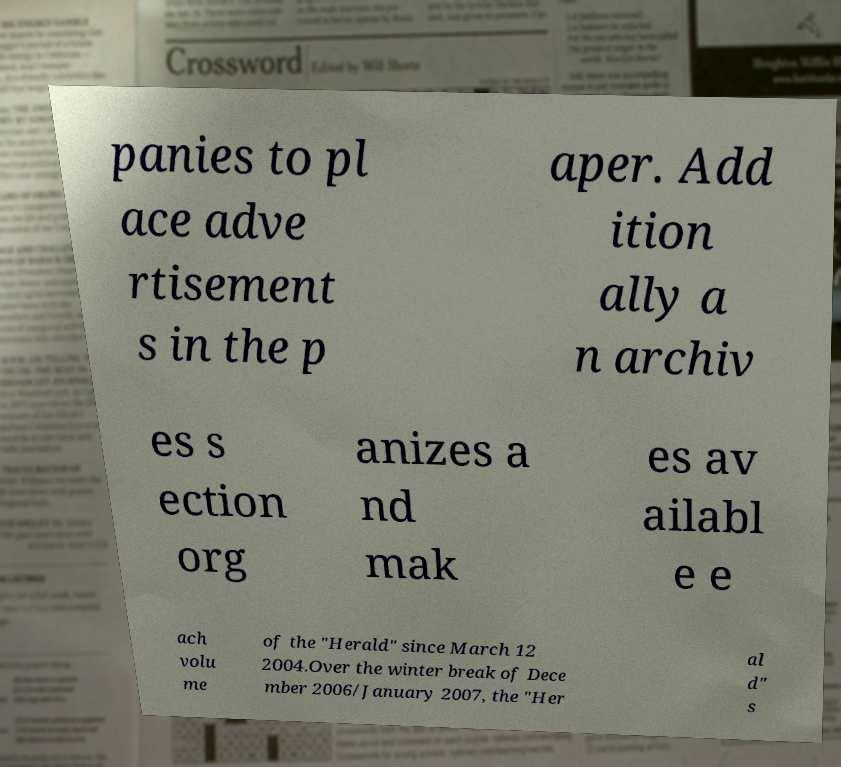Could you extract and type out the text from this image? panies to pl ace adve rtisement s in the p aper. Add ition ally a n archiv es s ection org anizes a nd mak es av ailabl e e ach volu me of the "Herald" since March 12 2004.Over the winter break of Dece mber 2006/January 2007, the "Her al d" s 